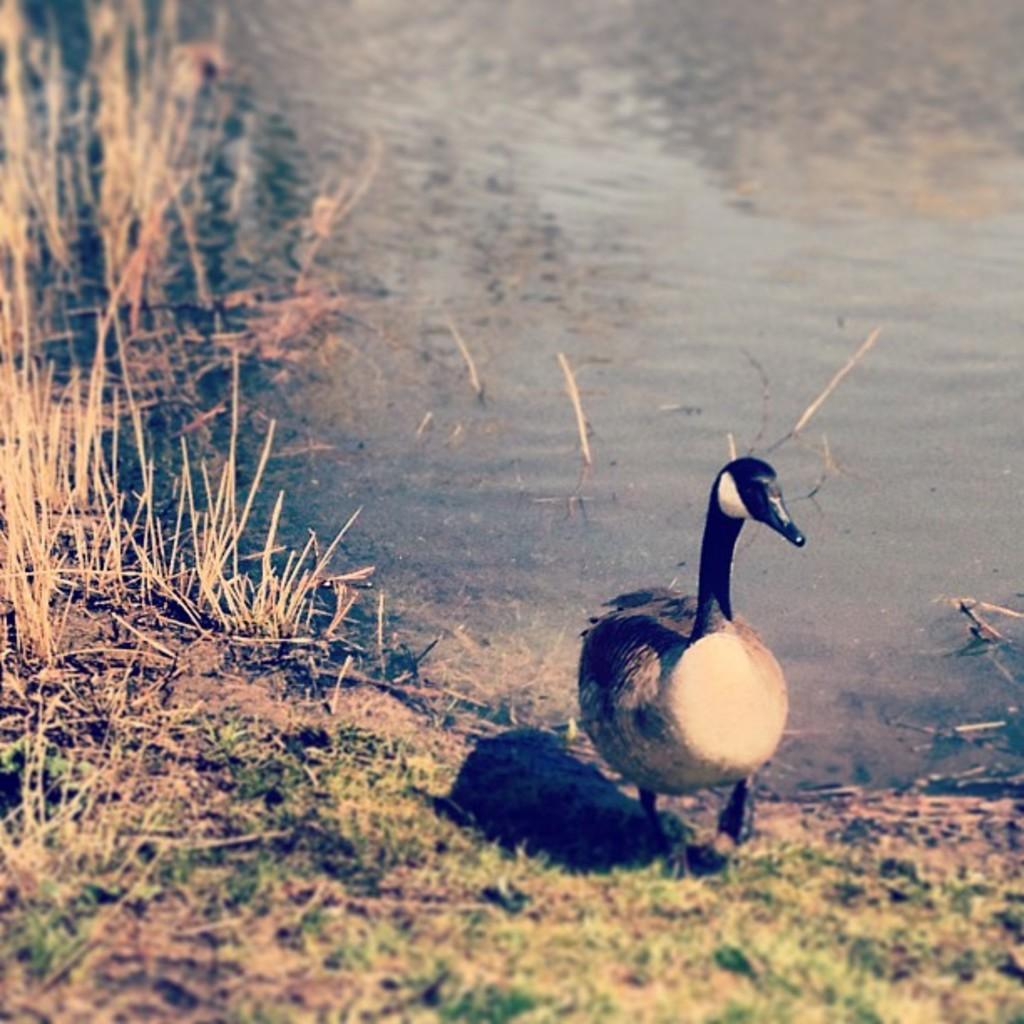What is the main feature of the image? There is a water body in the image. What can be seen in the foreground of the image? The ground with grass and shrub is visible in the foreground. Can you describe any living creatures in the image? Yes, a bird is walking in the image. Where is the scarecrow standing in the image? There is no scarecrow present in the image. What is the season of the bird's birth in the image? The image does not provide information about the bird's birth or the season. 